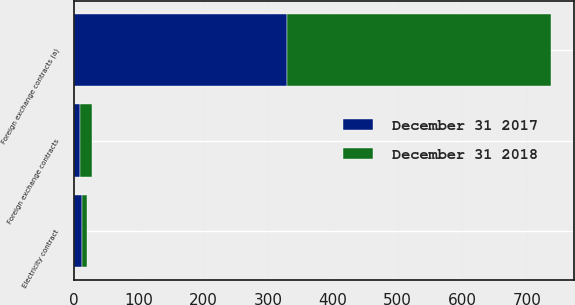Convert chart. <chart><loc_0><loc_0><loc_500><loc_500><stacked_bar_chart><ecel><fcel>Foreign exchange contracts (a)<fcel>Electricity contract<fcel>Foreign exchange contracts<nl><fcel>December 31 2018<fcel>407<fcel>8<fcel>19<nl><fcel>December 31 2017<fcel>329<fcel>13<fcel>10<nl></chart> 